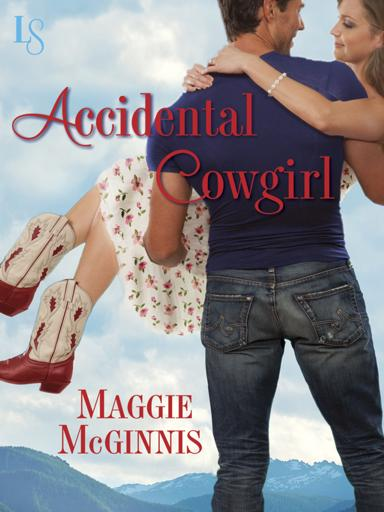What emotions do the poses of the man and woman convey in the image? The man and woman's poses convey a sense of joy and comfort. The woman, with her legs gracefully lifted, wraps her arms around the man in a carefree manner. The man's strong hold around her waist suggests protectiveness and affection, reinforcing the theme of love and support. 